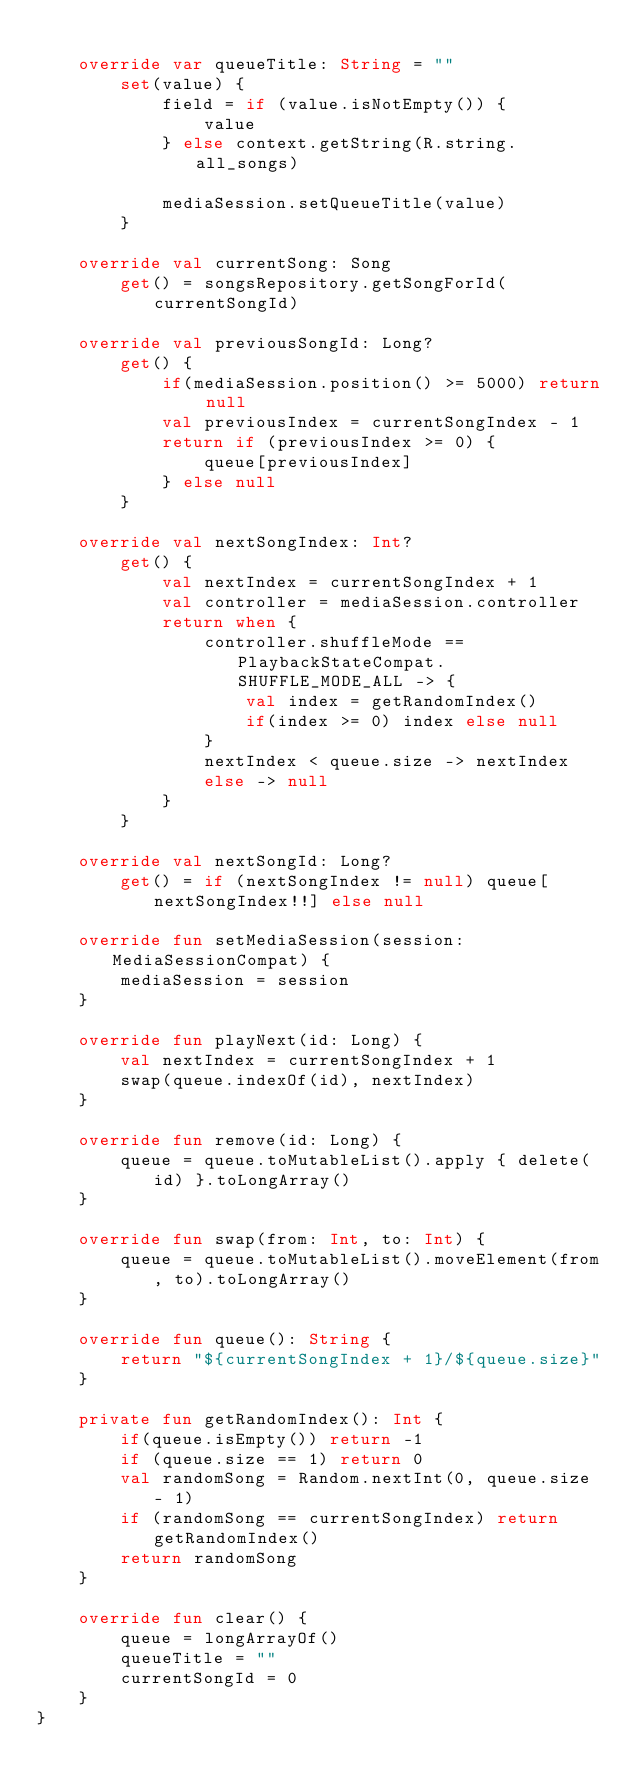Convert code to text. <code><loc_0><loc_0><loc_500><loc_500><_Kotlin_>
    override var queueTitle: String = ""
        set(value) {
            field = if (value.isNotEmpty()) {
                value
            } else context.getString(R.string.all_songs)

            mediaSession.setQueueTitle(value)
        }

    override val currentSong: Song
        get() = songsRepository.getSongForId(currentSongId)

    override val previousSongId: Long?
        get() {
            if(mediaSession.position() >= 5000) return null
            val previousIndex = currentSongIndex - 1
            return if (previousIndex >= 0) {
                queue[previousIndex]
            } else null
        }

    override val nextSongIndex: Int?
        get() {
            val nextIndex = currentSongIndex + 1
            val controller = mediaSession.controller
            return when {
                controller.shuffleMode == PlaybackStateCompat.SHUFFLE_MODE_ALL -> {
                    val index = getRandomIndex()
                    if(index >= 0) index else null
                }
                nextIndex < queue.size -> nextIndex
                else -> null
            }
        }

    override val nextSongId: Long?
        get() = if (nextSongIndex != null) queue[nextSongIndex!!] else null

    override fun setMediaSession(session: MediaSessionCompat) {
        mediaSession = session
    }

    override fun playNext(id: Long) {
        val nextIndex = currentSongIndex + 1
        swap(queue.indexOf(id), nextIndex)
    }

    override fun remove(id: Long) {
        queue = queue.toMutableList().apply { delete(id) }.toLongArray()
    }

    override fun swap(from: Int, to: Int) {
        queue = queue.toMutableList().moveElement(from, to).toLongArray()
    }

    override fun queue(): String {
        return "${currentSongIndex + 1}/${queue.size}"
    }

    private fun getRandomIndex(): Int {
        if(queue.isEmpty()) return -1
        if (queue.size == 1) return 0
        val randomSong = Random.nextInt(0, queue.size - 1)
        if (randomSong == currentSongIndex) return getRandomIndex()
        return randomSong
    }

    override fun clear() {
        queue = longArrayOf()
        queueTitle = ""
        currentSongId = 0
    }
}</code> 